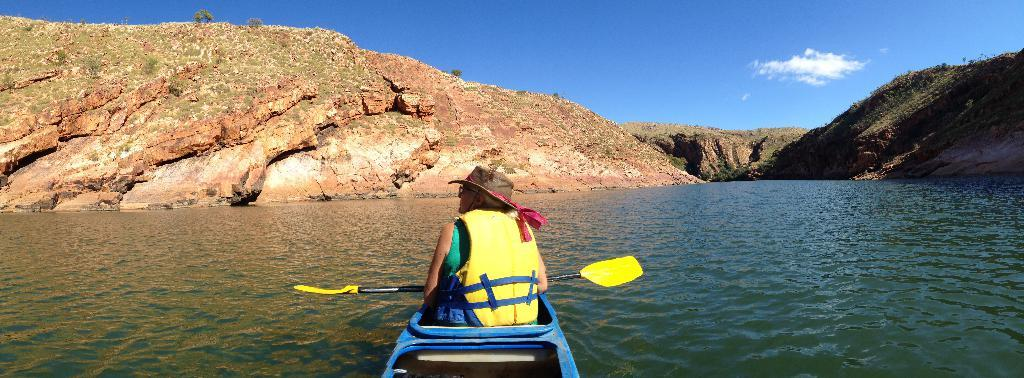What is the person in the image doing? There is a person sitting on a boat in the image. What type of natural environment can be seen in the image? There are trees, mountains, and a river visible in the image. What is visible in the sky in the image? The sky is visible in the image. What type of crown is the person wearing in the image? There is no crown visible in the image; the person is simply sitting on a boat. What type of structure can be seen in the image? There is no specific structure mentioned in the provided facts, only natural elements like trees, mountains, and a river. 